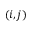Convert formula to latex. <formula><loc_0><loc_0><loc_500><loc_500>\left ( i , j \right )</formula> 